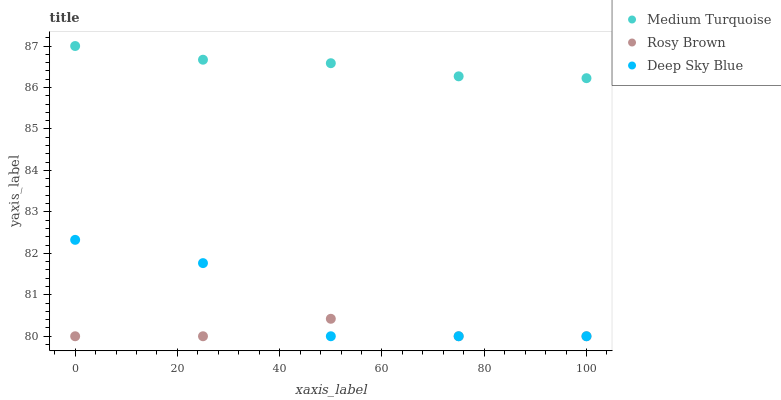Does Rosy Brown have the minimum area under the curve?
Answer yes or no. Yes. Does Medium Turquoise have the maximum area under the curve?
Answer yes or no. Yes. Does Deep Sky Blue have the minimum area under the curve?
Answer yes or no. No. Does Deep Sky Blue have the maximum area under the curve?
Answer yes or no. No. Is Medium Turquoise the smoothest?
Answer yes or no. Yes. Is Deep Sky Blue the roughest?
Answer yes or no. Yes. Is Deep Sky Blue the smoothest?
Answer yes or no. No. Is Medium Turquoise the roughest?
Answer yes or no. No. Does Rosy Brown have the lowest value?
Answer yes or no. Yes. Does Medium Turquoise have the lowest value?
Answer yes or no. No. Does Medium Turquoise have the highest value?
Answer yes or no. Yes. Does Deep Sky Blue have the highest value?
Answer yes or no. No. Is Deep Sky Blue less than Medium Turquoise?
Answer yes or no. Yes. Is Medium Turquoise greater than Rosy Brown?
Answer yes or no. Yes. Does Deep Sky Blue intersect Rosy Brown?
Answer yes or no. Yes. Is Deep Sky Blue less than Rosy Brown?
Answer yes or no. No. Is Deep Sky Blue greater than Rosy Brown?
Answer yes or no. No. Does Deep Sky Blue intersect Medium Turquoise?
Answer yes or no. No. 